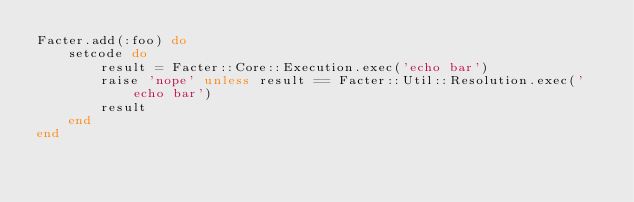<code> <loc_0><loc_0><loc_500><loc_500><_Ruby_>Facter.add(:foo) do
    setcode do
        result = Facter::Core::Execution.exec('echo bar')
        raise 'nope' unless result == Facter::Util::Resolution.exec('echo bar')
        result
    end
end
</code> 